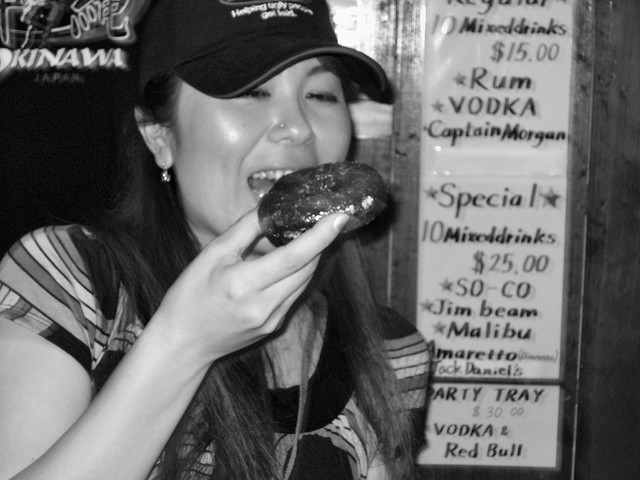Identify the text displayed in this image. $15.00 25.00 VODKA CO so Bull Red VODKA 30.00 TRAY PARTY JACK Daniel's maretto Malibu beam Jim MIXEDDRINKS 10 special Morgan captain Rum 10 MIXEDDRINKS KINAWA 